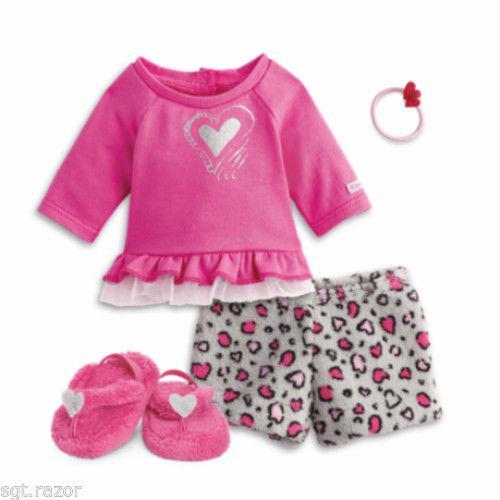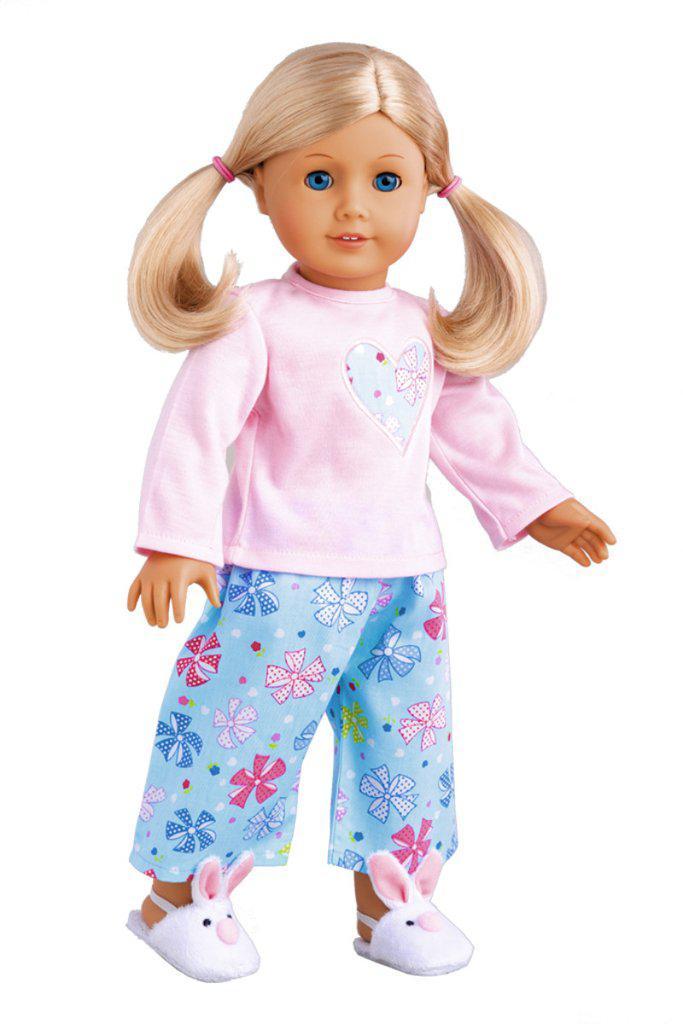The first image is the image on the left, the second image is the image on the right. Analyze the images presented: Is the assertion "there is a doll in pajamas and wearing white bunny slippers" valid? Answer yes or no. Yes. The first image is the image on the left, the second image is the image on the right. Analyze the images presented: Is the assertion "One image shows a doll wearing her hair in pigtails." valid? Answer yes or no. Yes. 